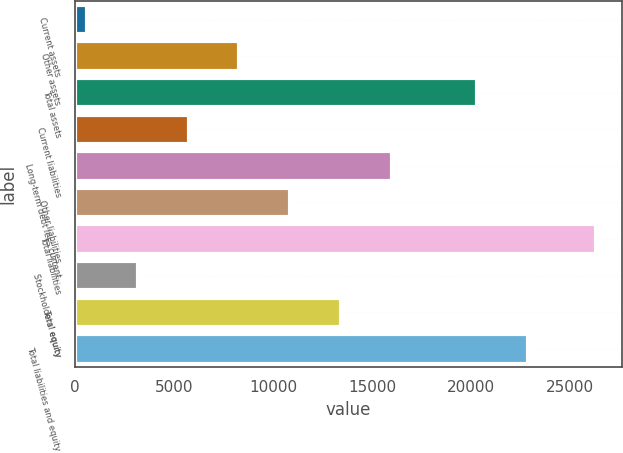<chart> <loc_0><loc_0><loc_500><loc_500><bar_chart><fcel>Current assets<fcel>Other assets<fcel>Total assets<fcel>Current liabilities<fcel>Long-term debt less current<fcel>Other liabilities<fcel>Total liabilities<fcel>Stockholders' equity<fcel>Total equity<fcel>Total liabilities and equity<nl><fcel>585<fcel>8298.6<fcel>20284<fcel>5727.4<fcel>16012.2<fcel>10869.8<fcel>26297<fcel>3156.2<fcel>13441<fcel>22855.2<nl></chart> 